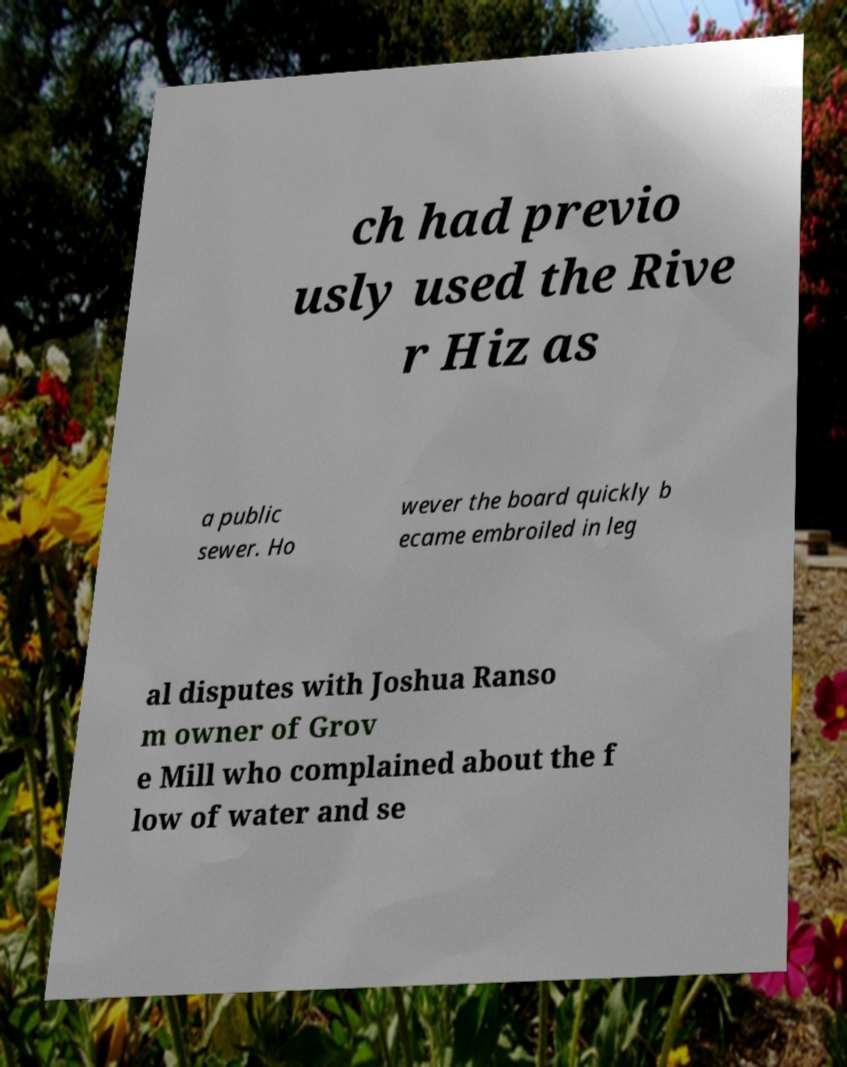Can you accurately transcribe the text from the provided image for me? ch had previo usly used the Rive r Hiz as a public sewer. Ho wever the board quickly b ecame embroiled in leg al disputes with Joshua Ranso m owner of Grov e Mill who complained about the f low of water and se 